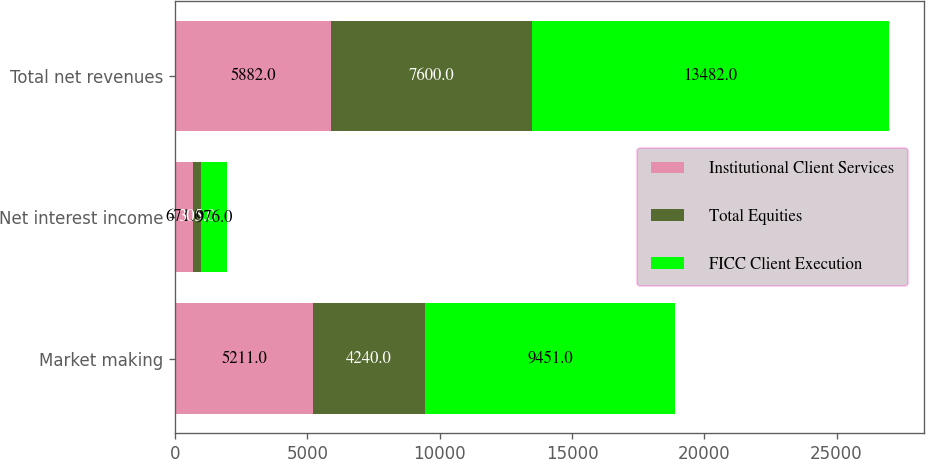Convert chart to OTSL. <chart><loc_0><loc_0><loc_500><loc_500><stacked_bar_chart><ecel><fcel>Market making<fcel>Net interest income<fcel>Total net revenues<nl><fcel>Institutional Client Services<fcel>5211<fcel>671<fcel>5882<nl><fcel>Total Equities<fcel>4240<fcel>305<fcel>7600<nl><fcel>FICC Client Execution<fcel>9451<fcel>976<fcel>13482<nl></chart> 